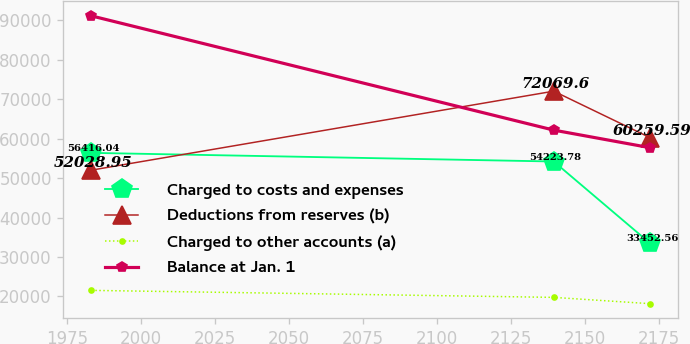Convert chart. <chart><loc_0><loc_0><loc_500><loc_500><line_chart><ecel><fcel>Charged to costs and expenses<fcel>Deductions from reserves (b)<fcel>Charged to other accounts (a)<fcel>Balance at Jan. 1<nl><fcel>1983.29<fcel>56416<fcel>52028.9<fcel>21527<fcel>91171.4<nl><fcel>2139.54<fcel>54223.8<fcel>72069.6<fcel>19751.1<fcel>62188.1<nl><fcel>2172.13<fcel>33452.6<fcel>60259.6<fcel>18151.5<fcel>57722.6<nl></chart> 